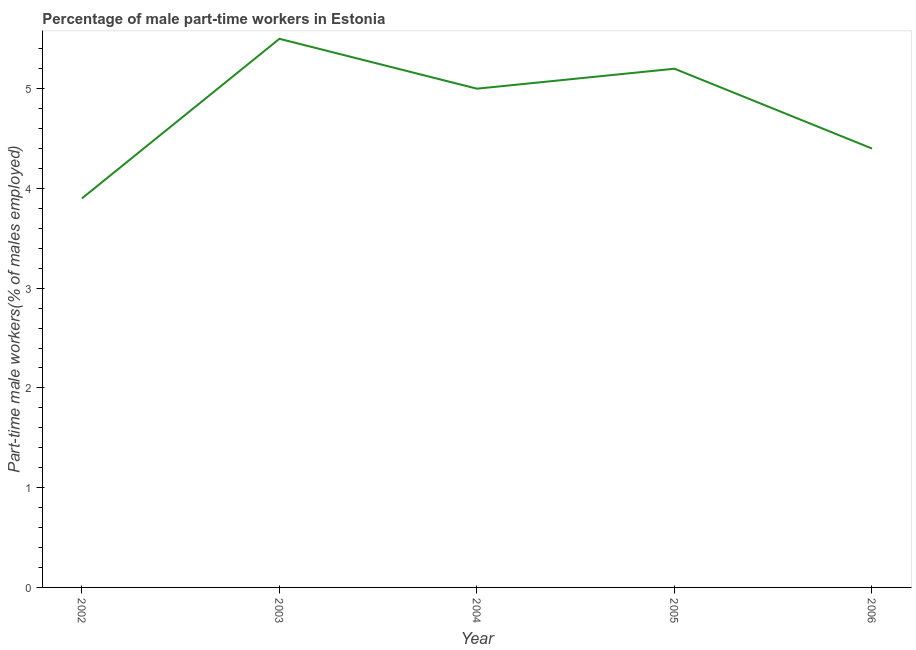What is the percentage of part-time male workers in 2006?
Provide a succinct answer. 4.4. Across all years, what is the minimum percentage of part-time male workers?
Ensure brevity in your answer.  3.9. In which year was the percentage of part-time male workers maximum?
Your response must be concise. 2003. What is the sum of the percentage of part-time male workers?
Make the answer very short. 24. What is the average percentage of part-time male workers per year?
Offer a very short reply. 4.8. What is the median percentage of part-time male workers?
Your response must be concise. 5. What is the ratio of the percentage of part-time male workers in 2005 to that in 2006?
Ensure brevity in your answer.  1.18. What is the difference between the highest and the second highest percentage of part-time male workers?
Give a very brief answer. 0.3. What is the difference between the highest and the lowest percentage of part-time male workers?
Provide a short and direct response. 1.6. In how many years, is the percentage of part-time male workers greater than the average percentage of part-time male workers taken over all years?
Make the answer very short. 3. Does the percentage of part-time male workers monotonically increase over the years?
Provide a succinct answer. No. How many lines are there?
Provide a succinct answer. 1. Does the graph contain any zero values?
Your answer should be very brief. No. What is the title of the graph?
Your answer should be very brief. Percentage of male part-time workers in Estonia. What is the label or title of the Y-axis?
Offer a very short reply. Part-time male workers(% of males employed). What is the Part-time male workers(% of males employed) in 2002?
Ensure brevity in your answer.  3.9. What is the Part-time male workers(% of males employed) in 2004?
Provide a short and direct response. 5. What is the Part-time male workers(% of males employed) of 2005?
Give a very brief answer. 5.2. What is the Part-time male workers(% of males employed) in 2006?
Make the answer very short. 4.4. What is the difference between the Part-time male workers(% of males employed) in 2002 and 2003?
Make the answer very short. -1.6. What is the difference between the Part-time male workers(% of males employed) in 2002 and 2006?
Keep it short and to the point. -0.5. What is the difference between the Part-time male workers(% of males employed) in 2003 and 2004?
Your answer should be very brief. 0.5. What is the difference between the Part-time male workers(% of males employed) in 2003 and 2006?
Ensure brevity in your answer.  1.1. What is the difference between the Part-time male workers(% of males employed) in 2004 and 2005?
Your answer should be compact. -0.2. What is the difference between the Part-time male workers(% of males employed) in 2004 and 2006?
Ensure brevity in your answer.  0.6. What is the ratio of the Part-time male workers(% of males employed) in 2002 to that in 2003?
Make the answer very short. 0.71. What is the ratio of the Part-time male workers(% of males employed) in 2002 to that in 2004?
Provide a succinct answer. 0.78. What is the ratio of the Part-time male workers(% of males employed) in 2002 to that in 2006?
Keep it short and to the point. 0.89. What is the ratio of the Part-time male workers(% of males employed) in 2003 to that in 2005?
Provide a short and direct response. 1.06. What is the ratio of the Part-time male workers(% of males employed) in 2003 to that in 2006?
Give a very brief answer. 1.25. What is the ratio of the Part-time male workers(% of males employed) in 2004 to that in 2006?
Give a very brief answer. 1.14. What is the ratio of the Part-time male workers(% of males employed) in 2005 to that in 2006?
Keep it short and to the point. 1.18. 